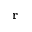<formula> <loc_0><loc_0><loc_500><loc_500>r</formula> 